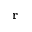<formula> <loc_0><loc_0><loc_500><loc_500>r</formula> 